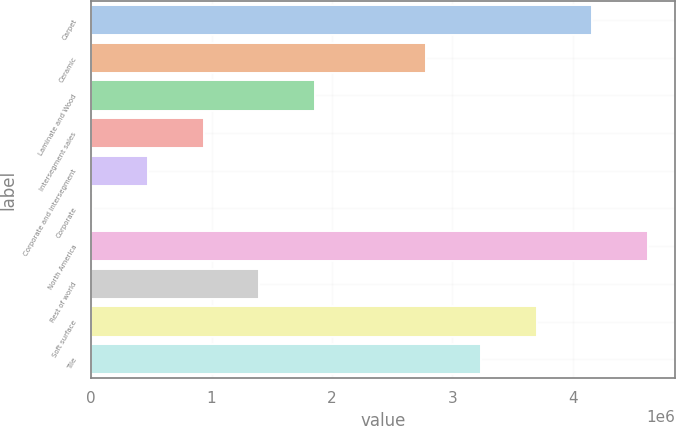<chart> <loc_0><loc_0><loc_500><loc_500><bar_chart><fcel>Carpet<fcel>Ceramic<fcel>Laminate and Wood<fcel>Intersegment sales<fcel>Corporate and intersegment<fcel>Corporate<fcel>North America<fcel>Rest of world<fcel>Soft surface<fcel>Tile<nl><fcel>4.15906e+06<fcel>2.77693e+06<fcel>1.85551e+06<fcel>934085<fcel>473375<fcel>12664<fcel>4.61977e+06<fcel>1.3948e+06<fcel>3.69835e+06<fcel>3.23764e+06<nl></chart> 